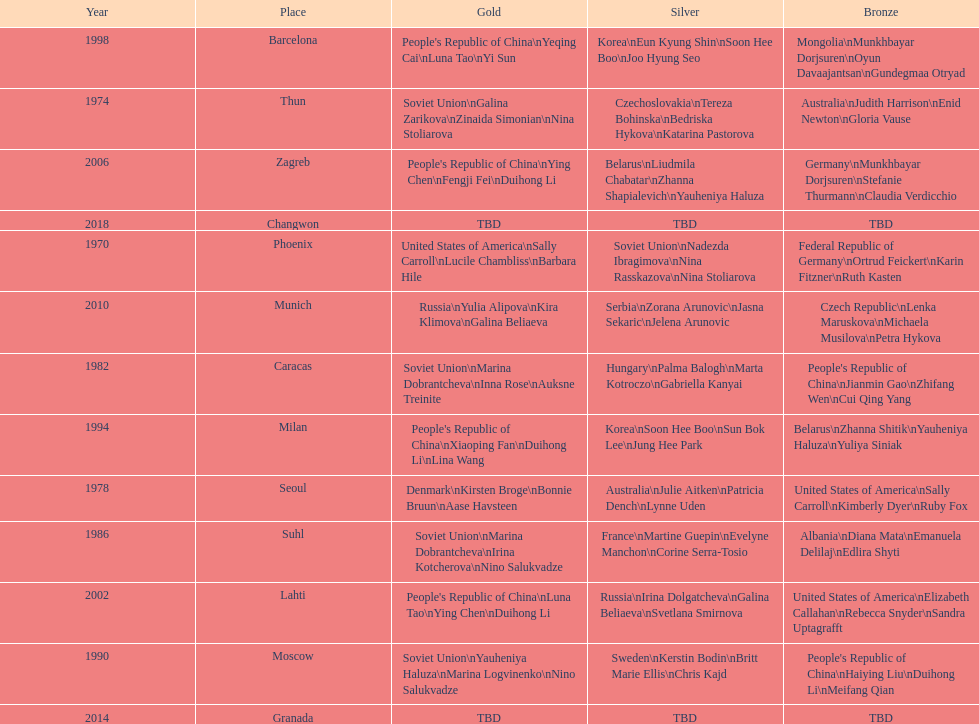Would you be able to parse every entry in this table? {'header': ['Year', 'Place', 'Gold', 'Silver', 'Bronze'], 'rows': [['1998', 'Barcelona', "People's Republic of China\\nYeqing Cai\\nLuna Tao\\nYi Sun", 'Korea\\nEun Kyung Shin\\nSoon Hee Boo\\nJoo Hyung Seo', 'Mongolia\\nMunkhbayar Dorjsuren\\nOyun Davaajantsan\\nGundegmaa Otryad'], ['1974', 'Thun', 'Soviet Union\\nGalina Zarikova\\nZinaida Simonian\\nNina Stoliarova', 'Czechoslovakia\\nTereza Bohinska\\nBedriska Hykova\\nKatarina Pastorova', 'Australia\\nJudith Harrison\\nEnid Newton\\nGloria Vause'], ['2006', 'Zagreb', "People's Republic of China\\nYing Chen\\nFengji Fei\\nDuihong Li", 'Belarus\\nLiudmila Chabatar\\nZhanna Shapialevich\\nYauheniya Haluza', 'Germany\\nMunkhbayar Dorjsuren\\nStefanie Thurmann\\nClaudia Verdicchio'], ['2018', 'Changwon', 'TBD', 'TBD', 'TBD'], ['1970', 'Phoenix', 'United States of America\\nSally Carroll\\nLucile Chambliss\\nBarbara Hile', 'Soviet Union\\nNadezda Ibragimova\\nNina Rasskazova\\nNina Stoliarova', 'Federal Republic of Germany\\nOrtrud Feickert\\nKarin Fitzner\\nRuth Kasten'], ['2010', 'Munich', 'Russia\\nYulia Alipova\\nKira Klimova\\nGalina Beliaeva', 'Serbia\\nZorana Arunovic\\nJasna Sekaric\\nJelena Arunovic', 'Czech Republic\\nLenka Maruskova\\nMichaela Musilova\\nPetra Hykova'], ['1982', 'Caracas', 'Soviet Union\\nMarina Dobrantcheva\\nInna Rose\\nAuksne Treinite', 'Hungary\\nPalma Balogh\\nMarta Kotroczo\\nGabriella Kanyai', "People's Republic of China\\nJianmin Gao\\nZhifang Wen\\nCui Qing Yang"], ['1994', 'Milan', "People's Republic of China\\nXiaoping Fan\\nDuihong Li\\nLina Wang", 'Korea\\nSoon Hee Boo\\nSun Bok Lee\\nJung Hee Park', 'Belarus\\nZhanna Shitik\\nYauheniya Haluza\\nYuliya Siniak'], ['1978', 'Seoul', 'Denmark\\nKirsten Broge\\nBonnie Bruun\\nAase Havsteen', 'Australia\\nJulie Aitken\\nPatricia Dench\\nLynne Uden', 'United States of America\\nSally Carroll\\nKimberly Dyer\\nRuby Fox'], ['1986', 'Suhl', 'Soviet Union\\nMarina Dobrantcheva\\nIrina Kotcherova\\nNino Salukvadze', 'France\\nMartine Guepin\\nEvelyne Manchon\\nCorine Serra-Tosio', 'Albania\\nDiana Mata\\nEmanuela Delilaj\\nEdlira Shyti'], ['2002', 'Lahti', "People's Republic of China\\nLuna Tao\\nYing Chen\\nDuihong Li", 'Russia\\nIrina Dolgatcheva\\nGalina Beliaeva\\nSvetlana Smirnova', 'United States of America\\nElizabeth Callahan\\nRebecca Snyder\\nSandra Uptagrafft'], ['1990', 'Moscow', 'Soviet Union\\nYauheniya Haluza\\nMarina Logvinenko\\nNino Salukvadze', 'Sweden\\nKerstin Bodin\\nBritt Marie Ellis\\nChris Kajd', "People's Republic of China\\nHaiying Liu\\nDuihong Li\\nMeifang Qian"], ['2014', 'Granada', 'TBD', 'TBD', 'TBD']]} Name one of the top three women to earn gold at the 1970 world championship held in phoenix, az Sally Carroll. 